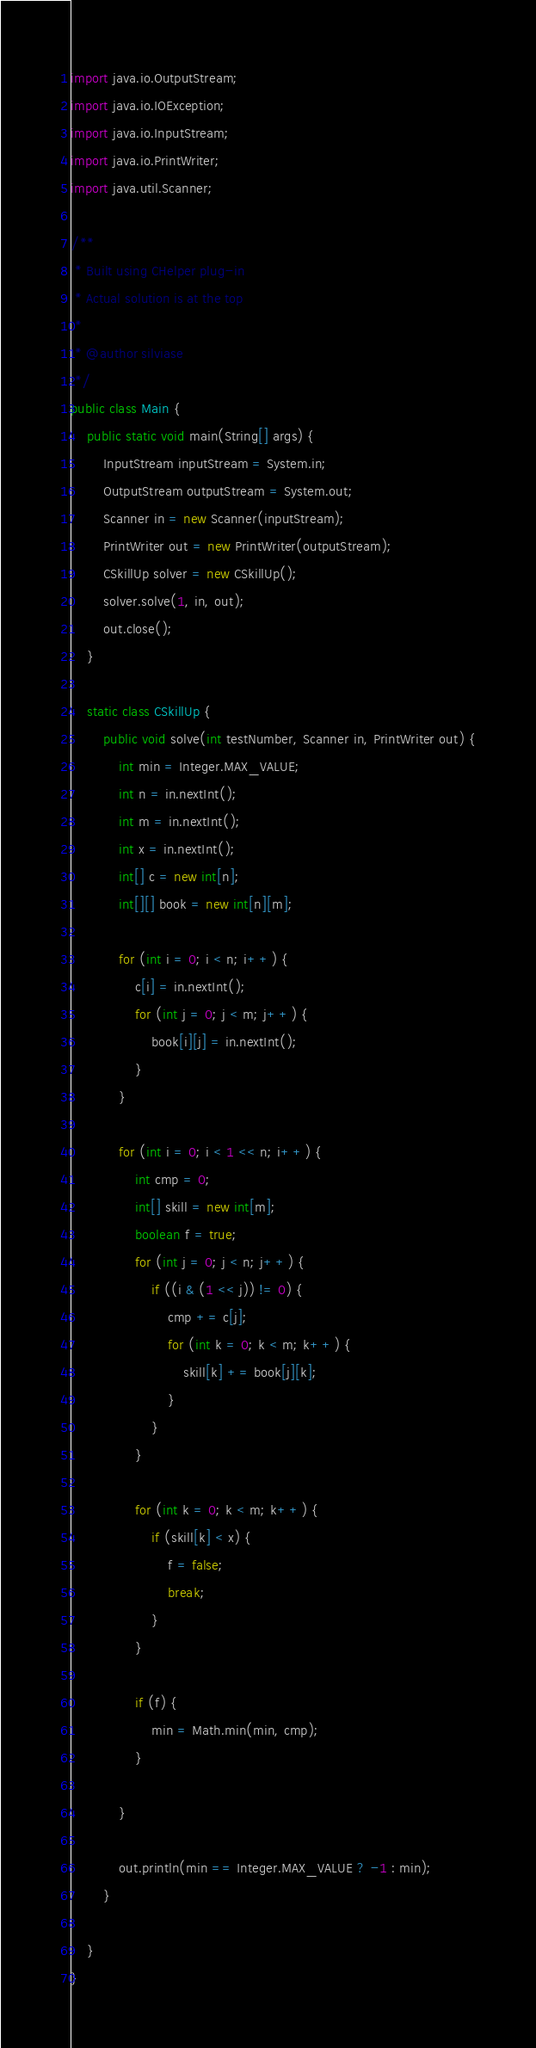<code> <loc_0><loc_0><loc_500><loc_500><_Java_>import java.io.OutputStream;
import java.io.IOException;
import java.io.InputStream;
import java.io.PrintWriter;
import java.util.Scanner;

/**
 * Built using CHelper plug-in
 * Actual solution is at the top
 *
 * @author silviase
 */
public class Main {
    public static void main(String[] args) {
        InputStream inputStream = System.in;
        OutputStream outputStream = System.out;
        Scanner in = new Scanner(inputStream);
        PrintWriter out = new PrintWriter(outputStream);
        CSkillUp solver = new CSkillUp();
        solver.solve(1, in, out);
        out.close();
    }

    static class CSkillUp {
        public void solve(int testNumber, Scanner in, PrintWriter out) {
            int min = Integer.MAX_VALUE;
            int n = in.nextInt();
            int m = in.nextInt();
            int x = in.nextInt();
            int[] c = new int[n];
            int[][] book = new int[n][m];

            for (int i = 0; i < n; i++) {
                c[i] = in.nextInt();
                for (int j = 0; j < m; j++) {
                    book[i][j] = in.nextInt();
                }
            }

            for (int i = 0; i < 1 << n; i++) {
                int cmp = 0;
                int[] skill = new int[m];
                boolean f = true;
                for (int j = 0; j < n; j++) {
                    if ((i & (1 << j)) != 0) {
                        cmp += c[j];
                        for (int k = 0; k < m; k++) {
                            skill[k] += book[j][k];
                        }
                    }
                }

                for (int k = 0; k < m; k++) {
                    if (skill[k] < x) {
                        f = false;
                        break;
                    }
                }

                if (f) {
                    min = Math.min(min, cmp);
                }

            }

            out.println(min == Integer.MAX_VALUE ? -1 : min);
        }

    }
}

</code> 